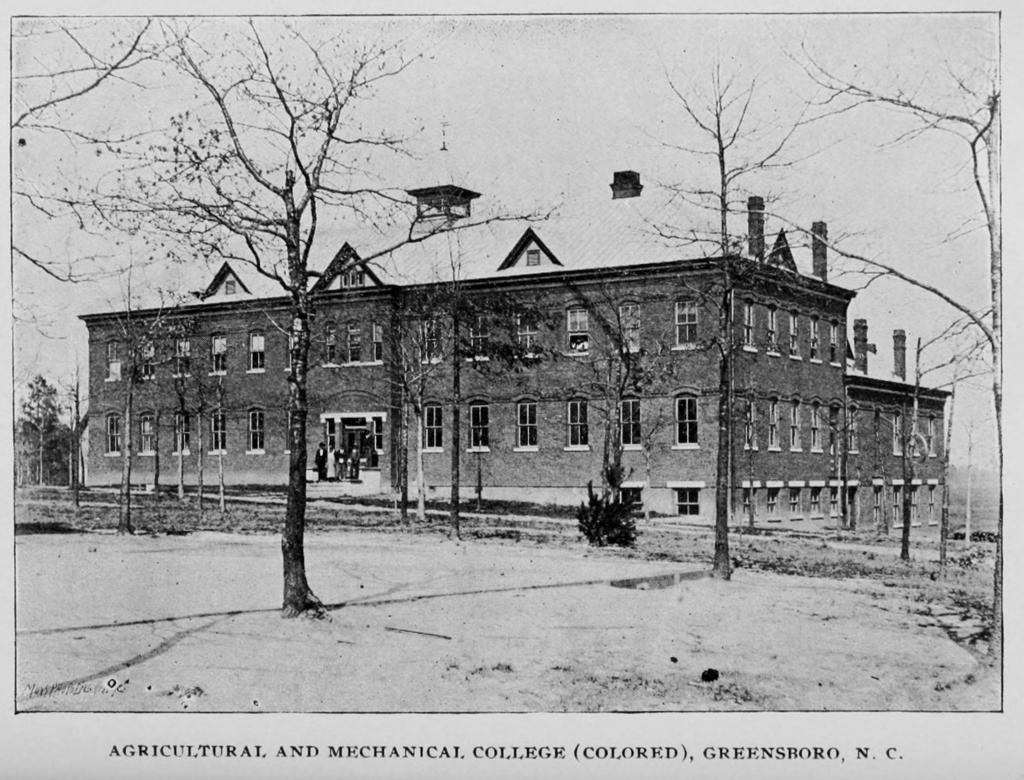How would you summarize this image in a sentence or two? This picture consists of a posters, in which there is a house in the center of the image, on which there are windows and trees in the image. 